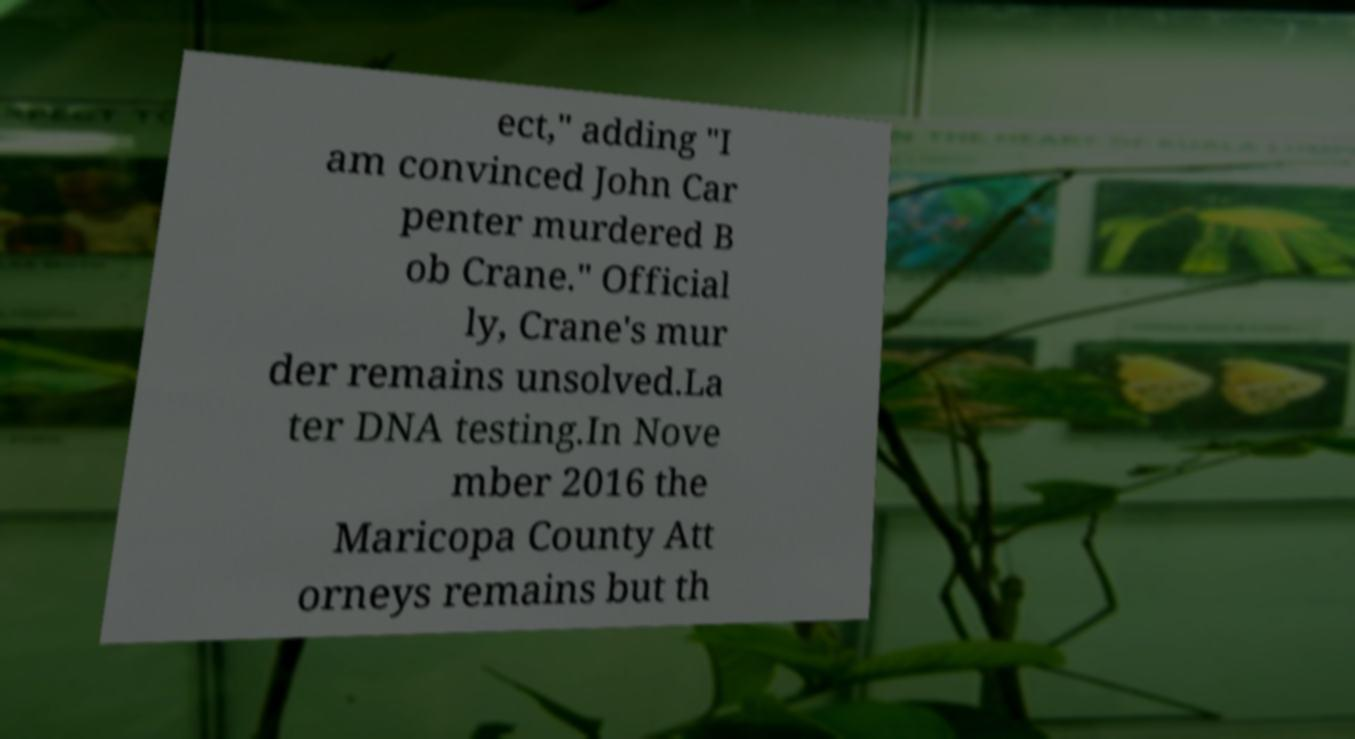Please read and relay the text visible in this image. What does it say? ect," adding "I am convinced John Car penter murdered B ob Crane." Official ly, Crane's mur der remains unsolved.La ter DNA testing.In Nove mber 2016 the Maricopa County Att orneys remains but th 